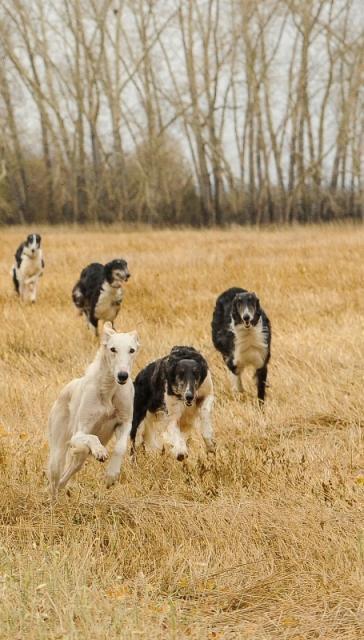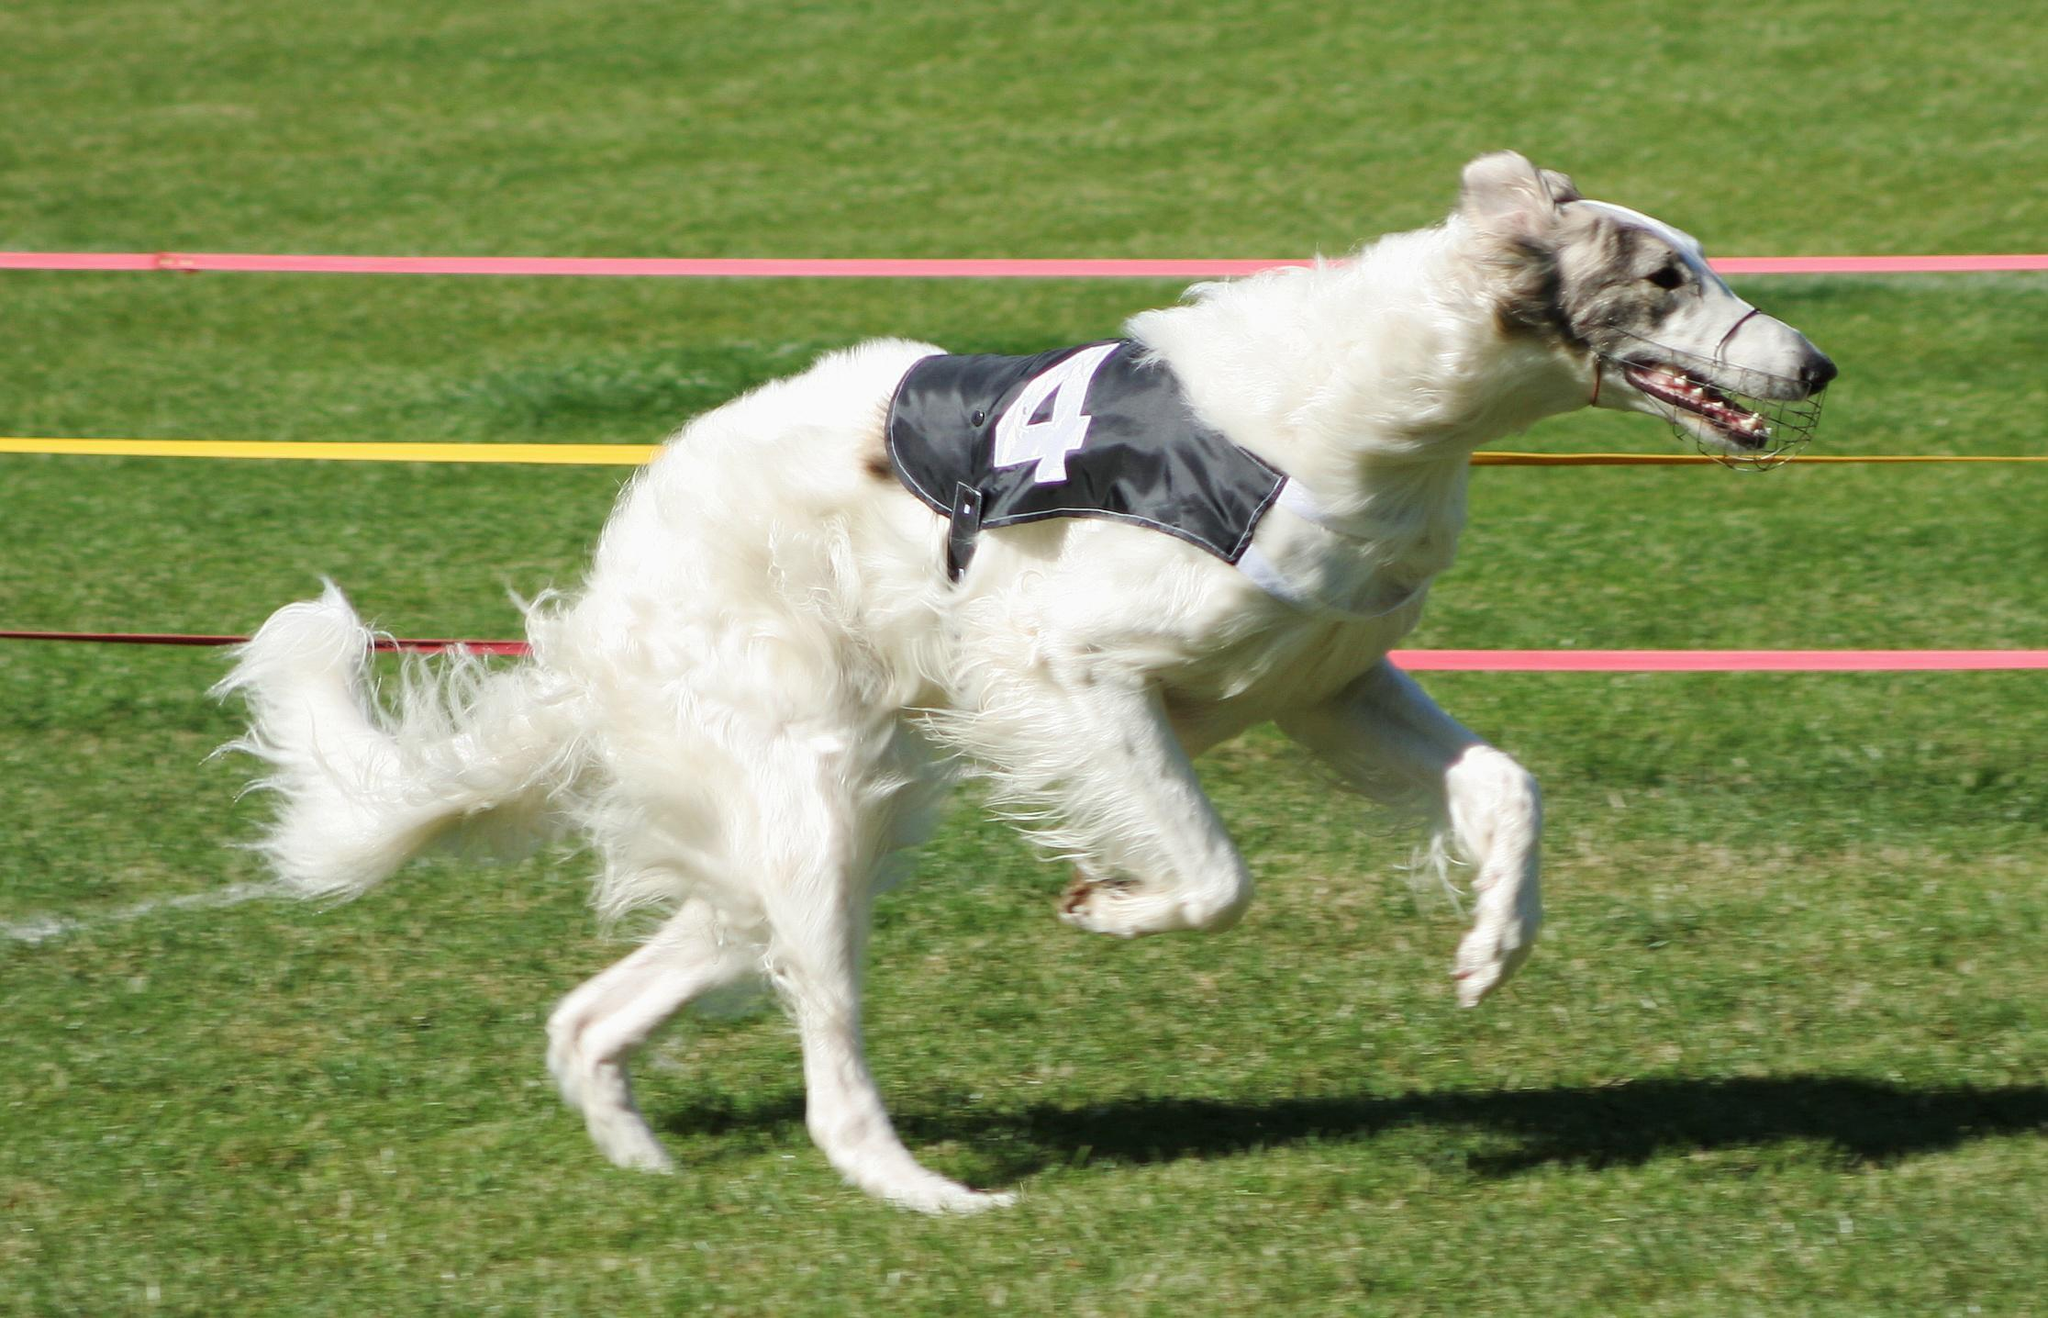The first image is the image on the left, the second image is the image on the right. Examine the images to the left and right. Is the description "The dog in the image on the right is running across the grass to the right side." accurate? Answer yes or no. Yes. The first image is the image on the left, the second image is the image on the right. Evaluate the accuracy of this statement regarding the images: "In total, at least two dogs are bounding across a field with front paws off the ground.". Is it true? Answer yes or no. Yes. 